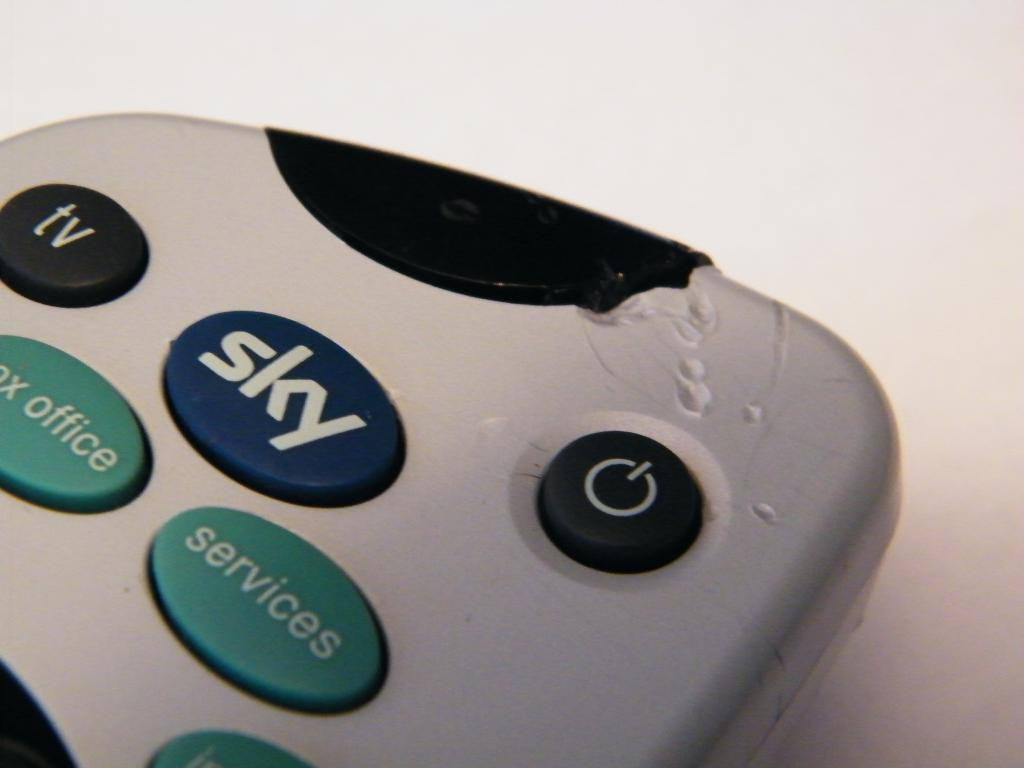<image>
Offer a succinct explanation of the picture presented. A gray remote that has a button that says Sky 